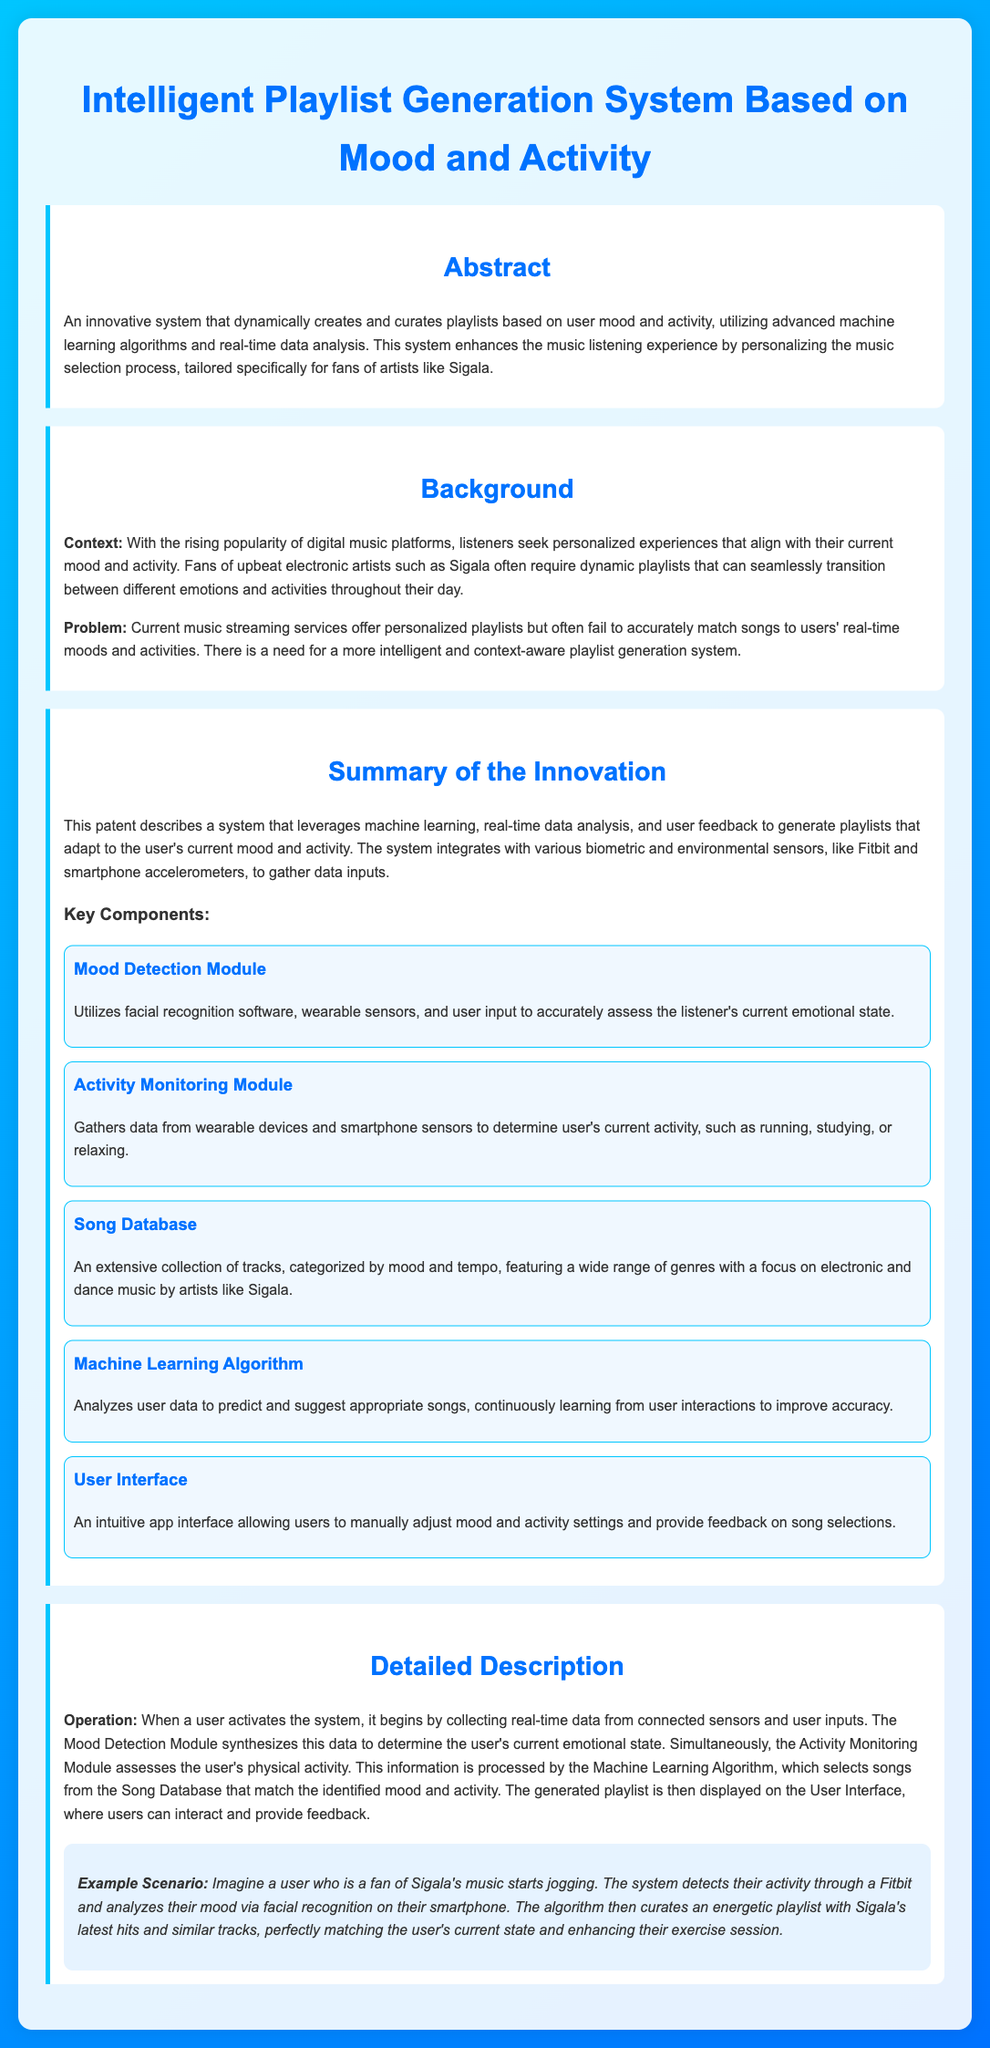What is the title of the patent? The title is the name given to the patent, which is "Intelligent Playlist Generation System Based on Mood and Activity."
Answer: Intelligent Playlist Generation System Based on Mood and Activity What key artist is mentioned in the document? The artist is highlighted as a primary focus within the document, indicating the type of music relevant to the system, which is Sigala.
Answer: Sigala What type of algorithms does the system utilize? Algorithms are specific computational methods mentioned in the document that are essential for the system's operation, specifically "machine learning algorithms."
Answer: machine learning algorithms Where does the system gather activity data from? The document specifies that the activity data is collected from "wearable devices and smartphone sensors."
Answer: wearable devices and smartphone sensors What is the purpose of the Mood Detection Module? This module serves a specific function in the system to accurately determine the listener's "current emotional state."
Answer: current emotional state What feature allows users to get real-time feedback on song selections? The interactive element of the application described in the document is a "User Interface."
Answer: User Interface How does the system adapt the playlists? The process involves analyzing user feedback and real-time data input to ensure playlists meet the user's needs, which is described as "continuously learning from user interactions."
Answer: continuously learning from user interactions What type of data inputs does the system use? The system is designed to utilize a variety of inputs, specifically "biometric and environmental sensors."
Answer: biometric and environmental sensors What is one scenario described in the document? The example given illustrates how the system operates when the user is "jogging."
Answer: jogging 